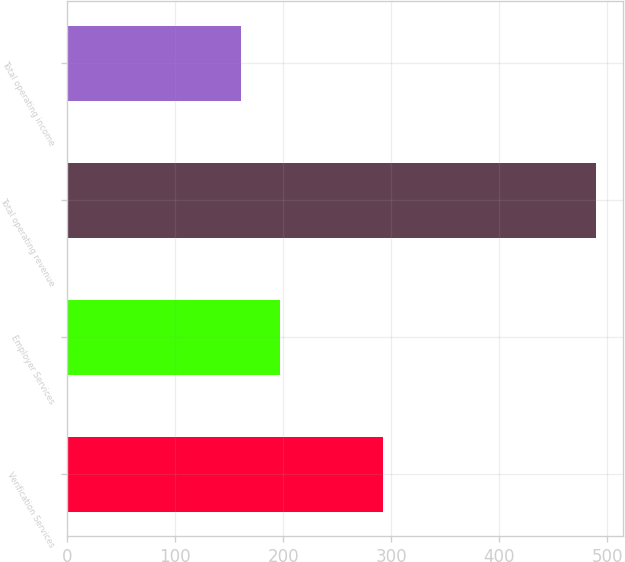Convert chart to OTSL. <chart><loc_0><loc_0><loc_500><loc_500><bar_chart><fcel>Verification Services<fcel>Employer Services<fcel>Total operating revenue<fcel>Total operating income<nl><fcel>292.6<fcel>197.5<fcel>490.1<fcel>160.7<nl></chart> 